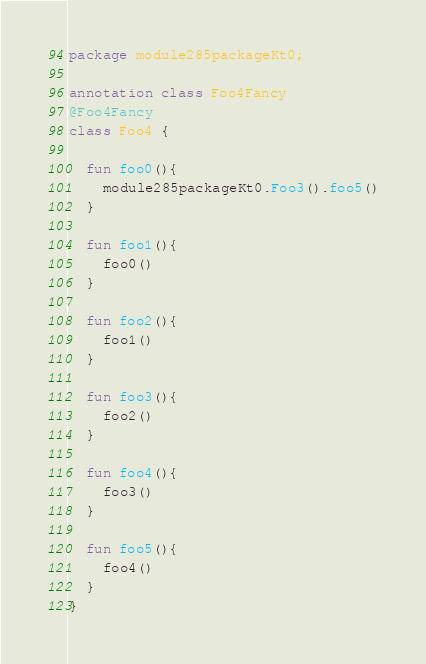<code> <loc_0><loc_0><loc_500><loc_500><_Kotlin_>package module285packageKt0;

annotation class Foo4Fancy
@Foo4Fancy
class Foo4 {

  fun foo0(){
    module285packageKt0.Foo3().foo5()
  }

  fun foo1(){
    foo0()
  }

  fun foo2(){
    foo1()
  }

  fun foo3(){
    foo2()
  }

  fun foo4(){
    foo3()
  }

  fun foo5(){
    foo4()
  }
}</code> 